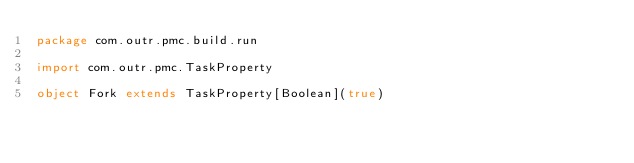Convert code to text. <code><loc_0><loc_0><loc_500><loc_500><_Scala_>package com.outr.pmc.build.run

import com.outr.pmc.TaskProperty

object Fork extends TaskProperty[Boolean](true)</code> 